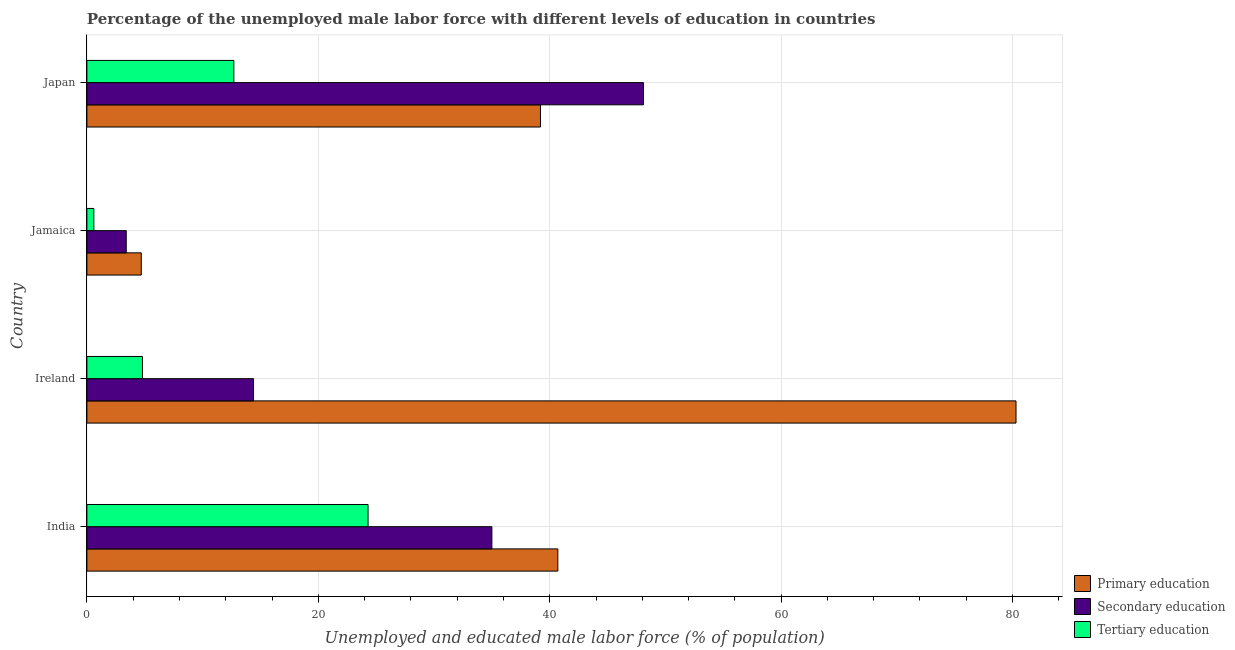How many groups of bars are there?
Make the answer very short. 4. What is the label of the 3rd group of bars from the top?
Provide a succinct answer. Ireland. In how many cases, is the number of bars for a given country not equal to the number of legend labels?
Keep it short and to the point. 0. What is the percentage of male labor force who received primary education in Ireland?
Make the answer very short. 80.3. Across all countries, what is the maximum percentage of male labor force who received secondary education?
Offer a terse response. 48.1. Across all countries, what is the minimum percentage of male labor force who received primary education?
Your answer should be compact. 4.7. In which country was the percentage of male labor force who received secondary education maximum?
Offer a very short reply. Japan. In which country was the percentage of male labor force who received tertiary education minimum?
Your answer should be very brief. Jamaica. What is the total percentage of male labor force who received primary education in the graph?
Offer a terse response. 164.9. What is the difference between the percentage of male labor force who received secondary education in Jamaica and the percentage of male labor force who received tertiary education in India?
Ensure brevity in your answer.  -20.9. What is the average percentage of male labor force who received secondary education per country?
Your answer should be compact. 25.23. What is the difference between the percentage of male labor force who received tertiary education and percentage of male labor force who received secondary education in India?
Your response must be concise. -10.7. In how many countries, is the percentage of male labor force who received primary education greater than 48 %?
Your answer should be very brief. 1. What is the ratio of the percentage of male labor force who received tertiary education in India to that in Jamaica?
Offer a very short reply. 40.5. Is the percentage of male labor force who received primary education in Ireland less than that in Jamaica?
Your response must be concise. No. What is the difference between the highest and the second highest percentage of male labor force who received secondary education?
Your answer should be compact. 13.1. What is the difference between the highest and the lowest percentage of male labor force who received primary education?
Keep it short and to the point. 75.6. What does the 2nd bar from the top in Ireland represents?
Keep it short and to the point. Secondary education. What does the 1st bar from the bottom in Jamaica represents?
Ensure brevity in your answer.  Primary education. Is it the case that in every country, the sum of the percentage of male labor force who received primary education and percentage of male labor force who received secondary education is greater than the percentage of male labor force who received tertiary education?
Make the answer very short. Yes. What is the difference between two consecutive major ticks on the X-axis?
Provide a succinct answer. 20. Are the values on the major ticks of X-axis written in scientific E-notation?
Your answer should be compact. No. How many legend labels are there?
Give a very brief answer. 3. How are the legend labels stacked?
Give a very brief answer. Vertical. What is the title of the graph?
Provide a succinct answer. Percentage of the unemployed male labor force with different levels of education in countries. What is the label or title of the X-axis?
Provide a succinct answer. Unemployed and educated male labor force (% of population). What is the Unemployed and educated male labor force (% of population) in Primary education in India?
Provide a succinct answer. 40.7. What is the Unemployed and educated male labor force (% of population) in Tertiary education in India?
Offer a terse response. 24.3. What is the Unemployed and educated male labor force (% of population) of Primary education in Ireland?
Your answer should be very brief. 80.3. What is the Unemployed and educated male labor force (% of population) of Secondary education in Ireland?
Offer a very short reply. 14.4. What is the Unemployed and educated male labor force (% of population) of Tertiary education in Ireland?
Provide a succinct answer. 4.8. What is the Unemployed and educated male labor force (% of population) in Primary education in Jamaica?
Ensure brevity in your answer.  4.7. What is the Unemployed and educated male labor force (% of population) of Secondary education in Jamaica?
Offer a very short reply. 3.4. What is the Unemployed and educated male labor force (% of population) of Tertiary education in Jamaica?
Keep it short and to the point. 0.6. What is the Unemployed and educated male labor force (% of population) in Primary education in Japan?
Provide a succinct answer. 39.2. What is the Unemployed and educated male labor force (% of population) of Secondary education in Japan?
Offer a terse response. 48.1. What is the Unemployed and educated male labor force (% of population) of Tertiary education in Japan?
Provide a short and direct response. 12.7. Across all countries, what is the maximum Unemployed and educated male labor force (% of population) of Primary education?
Offer a very short reply. 80.3. Across all countries, what is the maximum Unemployed and educated male labor force (% of population) in Secondary education?
Offer a very short reply. 48.1. Across all countries, what is the maximum Unemployed and educated male labor force (% of population) of Tertiary education?
Provide a short and direct response. 24.3. Across all countries, what is the minimum Unemployed and educated male labor force (% of population) in Primary education?
Offer a very short reply. 4.7. Across all countries, what is the minimum Unemployed and educated male labor force (% of population) of Secondary education?
Give a very brief answer. 3.4. Across all countries, what is the minimum Unemployed and educated male labor force (% of population) in Tertiary education?
Keep it short and to the point. 0.6. What is the total Unemployed and educated male labor force (% of population) of Primary education in the graph?
Your answer should be compact. 164.9. What is the total Unemployed and educated male labor force (% of population) of Secondary education in the graph?
Provide a succinct answer. 100.9. What is the total Unemployed and educated male labor force (% of population) in Tertiary education in the graph?
Keep it short and to the point. 42.4. What is the difference between the Unemployed and educated male labor force (% of population) of Primary education in India and that in Ireland?
Your answer should be compact. -39.6. What is the difference between the Unemployed and educated male labor force (% of population) in Secondary education in India and that in Ireland?
Your answer should be compact. 20.6. What is the difference between the Unemployed and educated male labor force (% of population) in Secondary education in India and that in Jamaica?
Keep it short and to the point. 31.6. What is the difference between the Unemployed and educated male labor force (% of population) of Tertiary education in India and that in Jamaica?
Your answer should be very brief. 23.7. What is the difference between the Unemployed and educated male labor force (% of population) in Primary education in India and that in Japan?
Your answer should be compact. 1.5. What is the difference between the Unemployed and educated male labor force (% of population) of Secondary education in India and that in Japan?
Give a very brief answer. -13.1. What is the difference between the Unemployed and educated male labor force (% of population) of Tertiary education in India and that in Japan?
Provide a succinct answer. 11.6. What is the difference between the Unemployed and educated male labor force (% of population) in Primary education in Ireland and that in Jamaica?
Make the answer very short. 75.6. What is the difference between the Unemployed and educated male labor force (% of population) in Primary education in Ireland and that in Japan?
Offer a terse response. 41.1. What is the difference between the Unemployed and educated male labor force (% of population) in Secondary education in Ireland and that in Japan?
Ensure brevity in your answer.  -33.7. What is the difference between the Unemployed and educated male labor force (% of population) of Tertiary education in Ireland and that in Japan?
Your response must be concise. -7.9. What is the difference between the Unemployed and educated male labor force (% of population) of Primary education in Jamaica and that in Japan?
Give a very brief answer. -34.5. What is the difference between the Unemployed and educated male labor force (% of population) in Secondary education in Jamaica and that in Japan?
Make the answer very short. -44.7. What is the difference between the Unemployed and educated male labor force (% of population) in Tertiary education in Jamaica and that in Japan?
Keep it short and to the point. -12.1. What is the difference between the Unemployed and educated male labor force (% of population) in Primary education in India and the Unemployed and educated male labor force (% of population) in Secondary education in Ireland?
Provide a short and direct response. 26.3. What is the difference between the Unemployed and educated male labor force (% of population) of Primary education in India and the Unemployed and educated male labor force (% of population) of Tertiary education in Ireland?
Offer a terse response. 35.9. What is the difference between the Unemployed and educated male labor force (% of population) in Secondary education in India and the Unemployed and educated male labor force (% of population) in Tertiary education in Ireland?
Offer a terse response. 30.2. What is the difference between the Unemployed and educated male labor force (% of population) in Primary education in India and the Unemployed and educated male labor force (% of population) in Secondary education in Jamaica?
Give a very brief answer. 37.3. What is the difference between the Unemployed and educated male labor force (% of population) of Primary education in India and the Unemployed and educated male labor force (% of population) of Tertiary education in Jamaica?
Your answer should be very brief. 40.1. What is the difference between the Unemployed and educated male labor force (% of population) in Secondary education in India and the Unemployed and educated male labor force (% of population) in Tertiary education in Jamaica?
Your answer should be very brief. 34.4. What is the difference between the Unemployed and educated male labor force (% of population) in Secondary education in India and the Unemployed and educated male labor force (% of population) in Tertiary education in Japan?
Make the answer very short. 22.3. What is the difference between the Unemployed and educated male labor force (% of population) in Primary education in Ireland and the Unemployed and educated male labor force (% of population) in Secondary education in Jamaica?
Your answer should be very brief. 76.9. What is the difference between the Unemployed and educated male labor force (% of population) in Primary education in Ireland and the Unemployed and educated male labor force (% of population) in Tertiary education in Jamaica?
Offer a very short reply. 79.7. What is the difference between the Unemployed and educated male labor force (% of population) in Secondary education in Ireland and the Unemployed and educated male labor force (% of population) in Tertiary education in Jamaica?
Ensure brevity in your answer.  13.8. What is the difference between the Unemployed and educated male labor force (% of population) in Primary education in Ireland and the Unemployed and educated male labor force (% of population) in Secondary education in Japan?
Ensure brevity in your answer.  32.2. What is the difference between the Unemployed and educated male labor force (% of population) of Primary education in Ireland and the Unemployed and educated male labor force (% of population) of Tertiary education in Japan?
Offer a terse response. 67.6. What is the difference between the Unemployed and educated male labor force (% of population) in Secondary education in Ireland and the Unemployed and educated male labor force (% of population) in Tertiary education in Japan?
Offer a very short reply. 1.7. What is the difference between the Unemployed and educated male labor force (% of population) in Primary education in Jamaica and the Unemployed and educated male labor force (% of population) in Secondary education in Japan?
Provide a short and direct response. -43.4. What is the difference between the Unemployed and educated male labor force (% of population) of Secondary education in Jamaica and the Unemployed and educated male labor force (% of population) of Tertiary education in Japan?
Make the answer very short. -9.3. What is the average Unemployed and educated male labor force (% of population) in Primary education per country?
Make the answer very short. 41.23. What is the average Unemployed and educated male labor force (% of population) of Secondary education per country?
Your answer should be very brief. 25.23. What is the difference between the Unemployed and educated male labor force (% of population) in Primary education and Unemployed and educated male labor force (% of population) in Secondary education in India?
Your response must be concise. 5.7. What is the difference between the Unemployed and educated male labor force (% of population) in Primary education and Unemployed and educated male labor force (% of population) in Tertiary education in India?
Your answer should be very brief. 16.4. What is the difference between the Unemployed and educated male labor force (% of population) in Secondary education and Unemployed and educated male labor force (% of population) in Tertiary education in India?
Your answer should be very brief. 10.7. What is the difference between the Unemployed and educated male labor force (% of population) in Primary education and Unemployed and educated male labor force (% of population) in Secondary education in Ireland?
Ensure brevity in your answer.  65.9. What is the difference between the Unemployed and educated male labor force (% of population) of Primary education and Unemployed and educated male labor force (% of population) of Tertiary education in Ireland?
Your response must be concise. 75.5. What is the difference between the Unemployed and educated male labor force (% of population) of Primary education and Unemployed and educated male labor force (% of population) of Tertiary education in Jamaica?
Offer a very short reply. 4.1. What is the difference between the Unemployed and educated male labor force (% of population) in Secondary education and Unemployed and educated male labor force (% of population) in Tertiary education in Japan?
Your response must be concise. 35.4. What is the ratio of the Unemployed and educated male labor force (% of population) in Primary education in India to that in Ireland?
Make the answer very short. 0.51. What is the ratio of the Unemployed and educated male labor force (% of population) in Secondary education in India to that in Ireland?
Make the answer very short. 2.43. What is the ratio of the Unemployed and educated male labor force (% of population) in Tertiary education in India to that in Ireland?
Make the answer very short. 5.06. What is the ratio of the Unemployed and educated male labor force (% of population) in Primary education in India to that in Jamaica?
Make the answer very short. 8.66. What is the ratio of the Unemployed and educated male labor force (% of population) in Secondary education in India to that in Jamaica?
Provide a short and direct response. 10.29. What is the ratio of the Unemployed and educated male labor force (% of population) of Tertiary education in India to that in Jamaica?
Your answer should be compact. 40.5. What is the ratio of the Unemployed and educated male labor force (% of population) in Primary education in India to that in Japan?
Give a very brief answer. 1.04. What is the ratio of the Unemployed and educated male labor force (% of population) of Secondary education in India to that in Japan?
Offer a very short reply. 0.73. What is the ratio of the Unemployed and educated male labor force (% of population) of Tertiary education in India to that in Japan?
Give a very brief answer. 1.91. What is the ratio of the Unemployed and educated male labor force (% of population) of Primary education in Ireland to that in Jamaica?
Provide a succinct answer. 17.09. What is the ratio of the Unemployed and educated male labor force (% of population) of Secondary education in Ireland to that in Jamaica?
Provide a short and direct response. 4.24. What is the ratio of the Unemployed and educated male labor force (% of population) of Primary education in Ireland to that in Japan?
Give a very brief answer. 2.05. What is the ratio of the Unemployed and educated male labor force (% of population) in Secondary education in Ireland to that in Japan?
Make the answer very short. 0.3. What is the ratio of the Unemployed and educated male labor force (% of population) in Tertiary education in Ireland to that in Japan?
Keep it short and to the point. 0.38. What is the ratio of the Unemployed and educated male labor force (% of population) in Primary education in Jamaica to that in Japan?
Your answer should be compact. 0.12. What is the ratio of the Unemployed and educated male labor force (% of population) of Secondary education in Jamaica to that in Japan?
Provide a succinct answer. 0.07. What is the ratio of the Unemployed and educated male labor force (% of population) of Tertiary education in Jamaica to that in Japan?
Make the answer very short. 0.05. What is the difference between the highest and the second highest Unemployed and educated male labor force (% of population) in Primary education?
Your answer should be compact. 39.6. What is the difference between the highest and the lowest Unemployed and educated male labor force (% of population) of Primary education?
Offer a very short reply. 75.6. What is the difference between the highest and the lowest Unemployed and educated male labor force (% of population) of Secondary education?
Keep it short and to the point. 44.7. What is the difference between the highest and the lowest Unemployed and educated male labor force (% of population) of Tertiary education?
Provide a succinct answer. 23.7. 